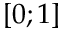<formula> <loc_0><loc_0><loc_500><loc_500>[ 0 ; 1 ]</formula> 